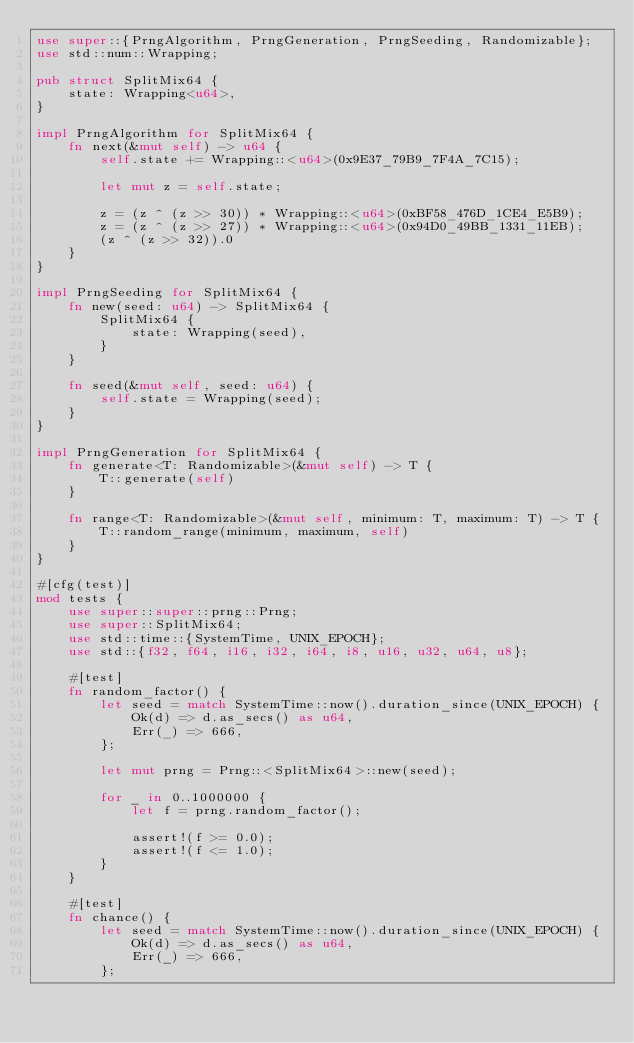<code> <loc_0><loc_0><loc_500><loc_500><_Rust_>use super::{PrngAlgorithm, PrngGeneration, PrngSeeding, Randomizable};
use std::num::Wrapping;

pub struct SplitMix64 {
    state: Wrapping<u64>,
}

impl PrngAlgorithm for SplitMix64 {
    fn next(&mut self) -> u64 {
        self.state += Wrapping::<u64>(0x9E37_79B9_7F4A_7C15);

        let mut z = self.state;

        z = (z ^ (z >> 30)) * Wrapping::<u64>(0xBF58_476D_1CE4_E5B9);
        z = (z ^ (z >> 27)) * Wrapping::<u64>(0x94D0_49BB_1331_11EB);
        (z ^ (z >> 32)).0
    }
}

impl PrngSeeding for SplitMix64 {
    fn new(seed: u64) -> SplitMix64 {
        SplitMix64 {
            state: Wrapping(seed),
        }
    }

    fn seed(&mut self, seed: u64) {
        self.state = Wrapping(seed);
    }
}

impl PrngGeneration for SplitMix64 {
    fn generate<T: Randomizable>(&mut self) -> T {
        T::generate(self)
    }

    fn range<T: Randomizable>(&mut self, minimum: T, maximum: T) -> T {
        T::random_range(minimum, maximum, self)
    }
}

#[cfg(test)]
mod tests {
    use super::super::prng::Prng;
    use super::SplitMix64;
    use std::time::{SystemTime, UNIX_EPOCH};
    use std::{f32, f64, i16, i32, i64, i8, u16, u32, u64, u8};

    #[test]
    fn random_factor() {
        let seed = match SystemTime::now().duration_since(UNIX_EPOCH) {
            Ok(d) => d.as_secs() as u64,
            Err(_) => 666,
        };

        let mut prng = Prng::<SplitMix64>::new(seed);

        for _ in 0..1000000 {
            let f = prng.random_factor();

            assert!(f >= 0.0);
            assert!(f <= 1.0);
        }
    }

    #[test]
    fn chance() {
        let seed = match SystemTime::now().duration_since(UNIX_EPOCH) {
            Ok(d) => d.as_secs() as u64,
            Err(_) => 666,
        };
</code> 